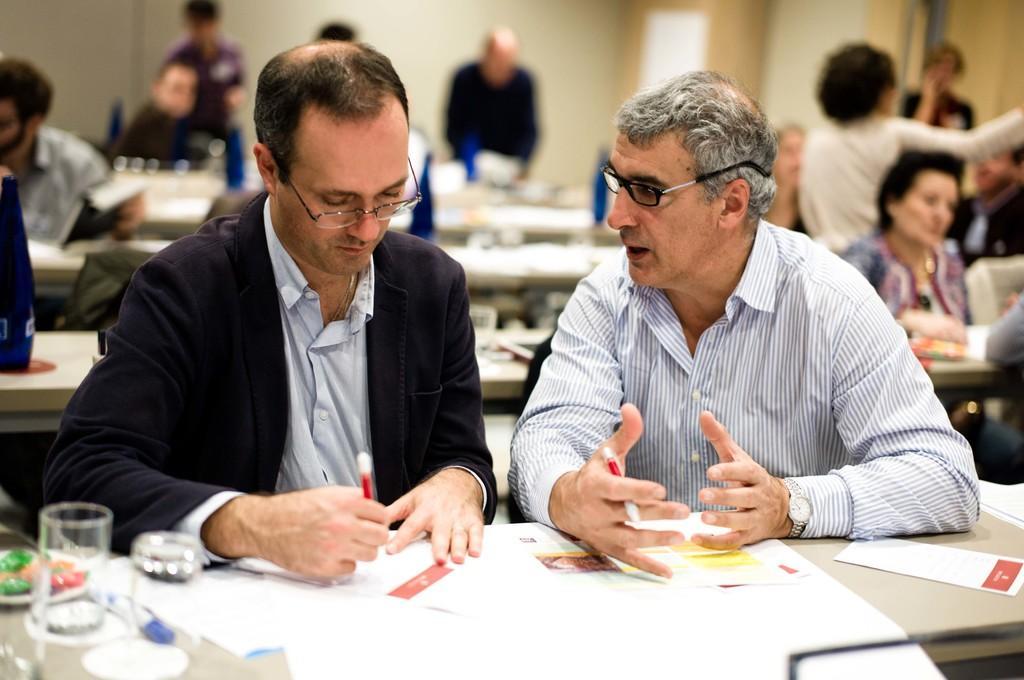Could you give a brief overview of what you see in this image? In this picture we can see a group of people sitting on chairs and some people are standing and in front of them on tables we can see papers, glasses, bottles, pens and some objects and in the background we can see a door, walls. 